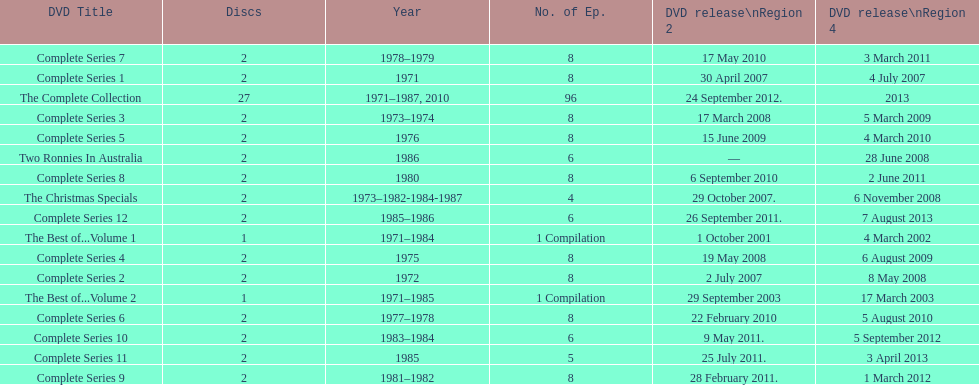What comes immediately after complete series 11? Complete Series 12. 